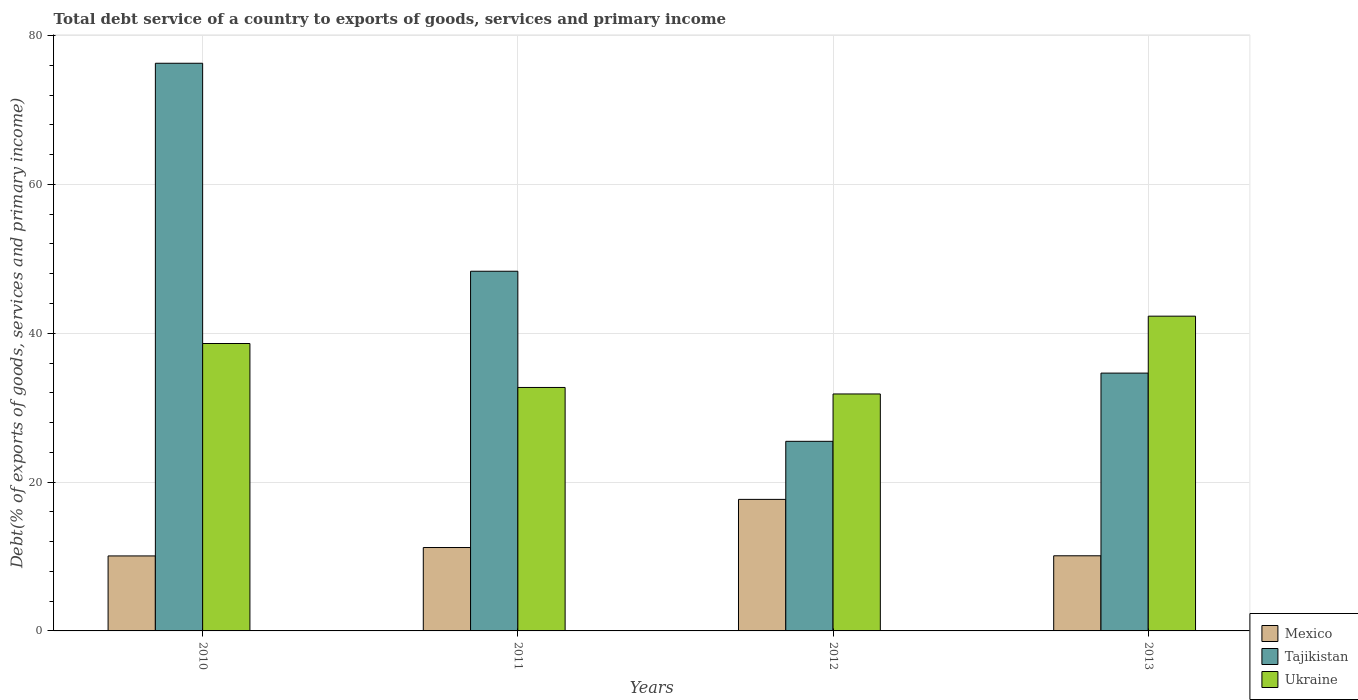How many groups of bars are there?
Give a very brief answer. 4. Are the number of bars per tick equal to the number of legend labels?
Make the answer very short. Yes. What is the label of the 3rd group of bars from the left?
Make the answer very short. 2012. In how many cases, is the number of bars for a given year not equal to the number of legend labels?
Make the answer very short. 0. What is the total debt service in Tajikistan in 2013?
Your answer should be very brief. 34.64. Across all years, what is the maximum total debt service in Mexico?
Your answer should be compact. 17.67. Across all years, what is the minimum total debt service in Mexico?
Offer a terse response. 10.08. What is the total total debt service in Mexico in the graph?
Provide a short and direct response. 49.06. What is the difference between the total debt service in Tajikistan in 2010 and that in 2013?
Give a very brief answer. 41.64. What is the difference between the total debt service in Mexico in 2011 and the total debt service in Tajikistan in 2010?
Make the answer very short. -65.07. What is the average total debt service in Mexico per year?
Offer a terse response. 12.26. In the year 2010, what is the difference between the total debt service in Tajikistan and total debt service in Ukraine?
Offer a terse response. 37.66. In how many years, is the total debt service in Ukraine greater than 56 %?
Offer a terse response. 0. What is the ratio of the total debt service in Mexico in 2011 to that in 2013?
Offer a very short reply. 1.11. What is the difference between the highest and the second highest total debt service in Mexico?
Keep it short and to the point. 6.47. What is the difference between the highest and the lowest total debt service in Mexico?
Your answer should be compact. 7.6. In how many years, is the total debt service in Mexico greater than the average total debt service in Mexico taken over all years?
Your response must be concise. 1. What does the 2nd bar from the left in 2012 represents?
Your answer should be very brief. Tajikistan. What does the 1st bar from the right in 2012 represents?
Provide a short and direct response. Ukraine. Is it the case that in every year, the sum of the total debt service in Ukraine and total debt service in Tajikistan is greater than the total debt service in Mexico?
Your response must be concise. Yes. How many years are there in the graph?
Your answer should be compact. 4. Are the values on the major ticks of Y-axis written in scientific E-notation?
Give a very brief answer. No. Does the graph contain grids?
Give a very brief answer. Yes. How many legend labels are there?
Your answer should be compact. 3. How are the legend labels stacked?
Your answer should be compact. Vertical. What is the title of the graph?
Your answer should be compact. Total debt service of a country to exports of goods, services and primary income. Does "Austria" appear as one of the legend labels in the graph?
Provide a succinct answer. No. What is the label or title of the X-axis?
Provide a short and direct response. Years. What is the label or title of the Y-axis?
Ensure brevity in your answer.  Debt(% of exports of goods, services and primary income). What is the Debt(% of exports of goods, services and primary income) of Mexico in 2010?
Provide a short and direct response. 10.08. What is the Debt(% of exports of goods, services and primary income) of Tajikistan in 2010?
Make the answer very short. 76.28. What is the Debt(% of exports of goods, services and primary income) in Ukraine in 2010?
Offer a terse response. 38.62. What is the Debt(% of exports of goods, services and primary income) of Mexico in 2011?
Keep it short and to the point. 11.21. What is the Debt(% of exports of goods, services and primary income) of Tajikistan in 2011?
Provide a succinct answer. 48.33. What is the Debt(% of exports of goods, services and primary income) in Ukraine in 2011?
Keep it short and to the point. 32.72. What is the Debt(% of exports of goods, services and primary income) in Mexico in 2012?
Your response must be concise. 17.67. What is the Debt(% of exports of goods, services and primary income) in Tajikistan in 2012?
Provide a short and direct response. 25.48. What is the Debt(% of exports of goods, services and primary income) of Ukraine in 2012?
Offer a very short reply. 31.84. What is the Debt(% of exports of goods, services and primary income) of Mexico in 2013?
Your response must be concise. 10.1. What is the Debt(% of exports of goods, services and primary income) in Tajikistan in 2013?
Your answer should be compact. 34.64. What is the Debt(% of exports of goods, services and primary income) of Ukraine in 2013?
Your response must be concise. 42.3. Across all years, what is the maximum Debt(% of exports of goods, services and primary income) of Mexico?
Keep it short and to the point. 17.67. Across all years, what is the maximum Debt(% of exports of goods, services and primary income) in Tajikistan?
Keep it short and to the point. 76.28. Across all years, what is the maximum Debt(% of exports of goods, services and primary income) in Ukraine?
Your response must be concise. 42.3. Across all years, what is the minimum Debt(% of exports of goods, services and primary income) in Mexico?
Ensure brevity in your answer.  10.08. Across all years, what is the minimum Debt(% of exports of goods, services and primary income) in Tajikistan?
Offer a terse response. 25.48. Across all years, what is the minimum Debt(% of exports of goods, services and primary income) of Ukraine?
Provide a succinct answer. 31.84. What is the total Debt(% of exports of goods, services and primary income) in Mexico in the graph?
Offer a terse response. 49.05. What is the total Debt(% of exports of goods, services and primary income) in Tajikistan in the graph?
Ensure brevity in your answer.  184.73. What is the total Debt(% of exports of goods, services and primary income) of Ukraine in the graph?
Offer a terse response. 145.47. What is the difference between the Debt(% of exports of goods, services and primary income) of Mexico in 2010 and that in 2011?
Offer a very short reply. -1.13. What is the difference between the Debt(% of exports of goods, services and primary income) of Tajikistan in 2010 and that in 2011?
Provide a short and direct response. 27.95. What is the difference between the Debt(% of exports of goods, services and primary income) of Ukraine in 2010 and that in 2011?
Keep it short and to the point. 5.91. What is the difference between the Debt(% of exports of goods, services and primary income) in Mexico in 2010 and that in 2012?
Make the answer very short. -7.6. What is the difference between the Debt(% of exports of goods, services and primary income) in Tajikistan in 2010 and that in 2012?
Provide a succinct answer. 50.8. What is the difference between the Debt(% of exports of goods, services and primary income) of Ukraine in 2010 and that in 2012?
Your answer should be compact. 6.78. What is the difference between the Debt(% of exports of goods, services and primary income) in Mexico in 2010 and that in 2013?
Give a very brief answer. -0.02. What is the difference between the Debt(% of exports of goods, services and primary income) in Tajikistan in 2010 and that in 2013?
Offer a very short reply. 41.64. What is the difference between the Debt(% of exports of goods, services and primary income) of Ukraine in 2010 and that in 2013?
Ensure brevity in your answer.  -3.67. What is the difference between the Debt(% of exports of goods, services and primary income) of Mexico in 2011 and that in 2012?
Ensure brevity in your answer.  -6.47. What is the difference between the Debt(% of exports of goods, services and primary income) in Tajikistan in 2011 and that in 2012?
Your answer should be compact. 22.85. What is the difference between the Debt(% of exports of goods, services and primary income) in Ukraine in 2011 and that in 2012?
Your response must be concise. 0.87. What is the difference between the Debt(% of exports of goods, services and primary income) of Mexico in 2011 and that in 2013?
Offer a very short reply. 1.11. What is the difference between the Debt(% of exports of goods, services and primary income) of Tajikistan in 2011 and that in 2013?
Keep it short and to the point. 13.69. What is the difference between the Debt(% of exports of goods, services and primary income) of Ukraine in 2011 and that in 2013?
Provide a short and direct response. -9.58. What is the difference between the Debt(% of exports of goods, services and primary income) of Mexico in 2012 and that in 2013?
Your answer should be compact. 7.58. What is the difference between the Debt(% of exports of goods, services and primary income) in Tajikistan in 2012 and that in 2013?
Make the answer very short. -9.17. What is the difference between the Debt(% of exports of goods, services and primary income) in Ukraine in 2012 and that in 2013?
Offer a very short reply. -10.45. What is the difference between the Debt(% of exports of goods, services and primary income) of Mexico in 2010 and the Debt(% of exports of goods, services and primary income) of Tajikistan in 2011?
Make the answer very short. -38.25. What is the difference between the Debt(% of exports of goods, services and primary income) in Mexico in 2010 and the Debt(% of exports of goods, services and primary income) in Ukraine in 2011?
Ensure brevity in your answer.  -22.64. What is the difference between the Debt(% of exports of goods, services and primary income) of Tajikistan in 2010 and the Debt(% of exports of goods, services and primary income) of Ukraine in 2011?
Make the answer very short. 43.56. What is the difference between the Debt(% of exports of goods, services and primary income) in Mexico in 2010 and the Debt(% of exports of goods, services and primary income) in Tajikistan in 2012?
Ensure brevity in your answer.  -15.4. What is the difference between the Debt(% of exports of goods, services and primary income) in Mexico in 2010 and the Debt(% of exports of goods, services and primary income) in Ukraine in 2012?
Keep it short and to the point. -21.76. What is the difference between the Debt(% of exports of goods, services and primary income) in Tajikistan in 2010 and the Debt(% of exports of goods, services and primary income) in Ukraine in 2012?
Give a very brief answer. 44.44. What is the difference between the Debt(% of exports of goods, services and primary income) in Mexico in 2010 and the Debt(% of exports of goods, services and primary income) in Tajikistan in 2013?
Give a very brief answer. -24.57. What is the difference between the Debt(% of exports of goods, services and primary income) of Mexico in 2010 and the Debt(% of exports of goods, services and primary income) of Ukraine in 2013?
Provide a succinct answer. -32.22. What is the difference between the Debt(% of exports of goods, services and primary income) in Tajikistan in 2010 and the Debt(% of exports of goods, services and primary income) in Ukraine in 2013?
Provide a short and direct response. 33.98. What is the difference between the Debt(% of exports of goods, services and primary income) of Mexico in 2011 and the Debt(% of exports of goods, services and primary income) of Tajikistan in 2012?
Offer a terse response. -14.27. What is the difference between the Debt(% of exports of goods, services and primary income) of Mexico in 2011 and the Debt(% of exports of goods, services and primary income) of Ukraine in 2012?
Keep it short and to the point. -20.63. What is the difference between the Debt(% of exports of goods, services and primary income) in Tajikistan in 2011 and the Debt(% of exports of goods, services and primary income) in Ukraine in 2012?
Provide a succinct answer. 16.49. What is the difference between the Debt(% of exports of goods, services and primary income) in Mexico in 2011 and the Debt(% of exports of goods, services and primary income) in Tajikistan in 2013?
Your answer should be very brief. -23.44. What is the difference between the Debt(% of exports of goods, services and primary income) of Mexico in 2011 and the Debt(% of exports of goods, services and primary income) of Ukraine in 2013?
Offer a very short reply. -31.09. What is the difference between the Debt(% of exports of goods, services and primary income) of Tajikistan in 2011 and the Debt(% of exports of goods, services and primary income) of Ukraine in 2013?
Ensure brevity in your answer.  6.04. What is the difference between the Debt(% of exports of goods, services and primary income) of Mexico in 2012 and the Debt(% of exports of goods, services and primary income) of Tajikistan in 2013?
Your response must be concise. -16.97. What is the difference between the Debt(% of exports of goods, services and primary income) in Mexico in 2012 and the Debt(% of exports of goods, services and primary income) in Ukraine in 2013?
Ensure brevity in your answer.  -24.62. What is the difference between the Debt(% of exports of goods, services and primary income) in Tajikistan in 2012 and the Debt(% of exports of goods, services and primary income) in Ukraine in 2013?
Your response must be concise. -16.82. What is the average Debt(% of exports of goods, services and primary income) in Mexico per year?
Your response must be concise. 12.26. What is the average Debt(% of exports of goods, services and primary income) of Tajikistan per year?
Your response must be concise. 46.18. What is the average Debt(% of exports of goods, services and primary income) in Ukraine per year?
Provide a succinct answer. 36.37. In the year 2010, what is the difference between the Debt(% of exports of goods, services and primary income) of Mexico and Debt(% of exports of goods, services and primary income) of Tajikistan?
Your response must be concise. -66.2. In the year 2010, what is the difference between the Debt(% of exports of goods, services and primary income) of Mexico and Debt(% of exports of goods, services and primary income) of Ukraine?
Offer a terse response. -28.54. In the year 2010, what is the difference between the Debt(% of exports of goods, services and primary income) of Tajikistan and Debt(% of exports of goods, services and primary income) of Ukraine?
Keep it short and to the point. 37.66. In the year 2011, what is the difference between the Debt(% of exports of goods, services and primary income) of Mexico and Debt(% of exports of goods, services and primary income) of Tajikistan?
Offer a very short reply. -37.12. In the year 2011, what is the difference between the Debt(% of exports of goods, services and primary income) of Mexico and Debt(% of exports of goods, services and primary income) of Ukraine?
Provide a short and direct response. -21.51. In the year 2011, what is the difference between the Debt(% of exports of goods, services and primary income) in Tajikistan and Debt(% of exports of goods, services and primary income) in Ukraine?
Offer a very short reply. 15.62. In the year 2012, what is the difference between the Debt(% of exports of goods, services and primary income) of Mexico and Debt(% of exports of goods, services and primary income) of Tajikistan?
Provide a succinct answer. -7.8. In the year 2012, what is the difference between the Debt(% of exports of goods, services and primary income) in Mexico and Debt(% of exports of goods, services and primary income) in Ukraine?
Ensure brevity in your answer.  -14.17. In the year 2012, what is the difference between the Debt(% of exports of goods, services and primary income) in Tajikistan and Debt(% of exports of goods, services and primary income) in Ukraine?
Your response must be concise. -6.36. In the year 2013, what is the difference between the Debt(% of exports of goods, services and primary income) in Mexico and Debt(% of exports of goods, services and primary income) in Tajikistan?
Provide a succinct answer. -24.55. In the year 2013, what is the difference between the Debt(% of exports of goods, services and primary income) of Mexico and Debt(% of exports of goods, services and primary income) of Ukraine?
Keep it short and to the point. -32.2. In the year 2013, what is the difference between the Debt(% of exports of goods, services and primary income) in Tajikistan and Debt(% of exports of goods, services and primary income) in Ukraine?
Your answer should be compact. -7.65. What is the ratio of the Debt(% of exports of goods, services and primary income) of Mexico in 2010 to that in 2011?
Give a very brief answer. 0.9. What is the ratio of the Debt(% of exports of goods, services and primary income) of Tajikistan in 2010 to that in 2011?
Provide a short and direct response. 1.58. What is the ratio of the Debt(% of exports of goods, services and primary income) in Ukraine in 2010 to that in 2011?
Your answer should be compact. 1.18. What is the ratio of the Debt(% of exports of goods, services and primary income) in Mexico in 2010 to that in 2012?
Keep it short and to the point. 0.57. What is the ratio of the Debt(% of exports of goods, services and primary income) in Tajikistan in 2010 to that in 2012?
Your response must be concise. 2.99. What is the ratio of the Debt(% of exports of goods, services and primary income) in Ukraine in 2010 to that in 2012?
Give a very brief answer. 1.21. What is the ratio of the Debt(% of exports of goods, services and primary income) in Tajikistan in 2010 to that in 2013?
Provide a succinct answer. 2.2. What is the ratio of the Debt(% of exports of goods, services and primary income) of Ukraine in 2010 to that in 2013?
Offer a very short reply. 0.91. What is the ratio of the Debt(% of exports of goods, services and primary income) in Mexico in 2011 to that in 2012?
Offer a terse response. 0.63. What is the ratio of the Debt(% of exports of goods, services and primary income) in Tajikistan in 2011 to that in 2012?
Your answer should be compact. 1.9. What is the ratio of the Debt(% of exports of goods, services and primary income) of Ukraine in 2011 to that in 2012?
Provide a short and direct response. 1.03. What is the ratio of the Debt(% of exports of goods, services and primary income) in Mexico in 2011 to that in 2013?
Keep it short and to the point. 1.11. What is the ratio of the Debt(% of exports of goods, services and primary income) in Tajikistan in 2011 to that in 2013?
Keep it short and to the point. 1.4. What is the ratio of the Debt(% of exports of goods, services and primary income) of Ukraine in 2011 to that in 2013?
Give a very brief answer. 0.77. What is the ratio of the Debt(% of exports of goods, services and primary income) in Mexico in 2012 to that in 2013?
Ensure brevity in your answer.  1.75. What is the ratio of the Debt(% of exports of goods, services and primary income) in Tajikistan in 2012 to that in 2013?
Provide a short and direct response. 0.74. What is the ratio of the Debt(% of exports of goods, services and primary income) of Ukraine in 2012 to that in 2013?
Provide a short and direct response. 0.75. What is the difference between the highest and the second highest Debt(% of exports of goods, services and primary income) in Mexico?
Keep it short and to the point. 6.47. What is the difference between the highest and the second highest Debt(% of exports of goods, services and primary income) of Tajikistan?
Your answer should be very brief. 27.95. What is the difference between the highest and the second highest Debt(% of exports of goods, services and primary income) in Ukraine?
Your response must be concise. 3.67. What is the difference between the highest and the lowest Debt(% of exports of goods, services and primary income) of Mexico?
Your response must be concise. 7.6. What is the difference between the highest and the lowest Debt(% of exports of goods, services and primary income) in Tajikistan?
Ensure brevity in your answer.  50.8. What is the difference between the highest and the lowest Debt(% of exports of goods, services and primary income) in Ukraine?
Provide a succinct answer. 10.45. 